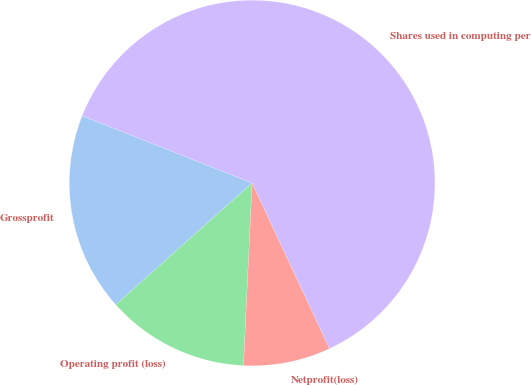<chart> <loc_0><loc_0><loc_500><loc_500><pie_chart><fcel>Grossprofit<fcel>Operating profit (loss)<fcel>Netprofit(loss)<fcel>Shares used in computing per<nl><fcel>17.59%<fcel>12.65%<fcel>7.71%<fcel>62.05%<nl></chart> 